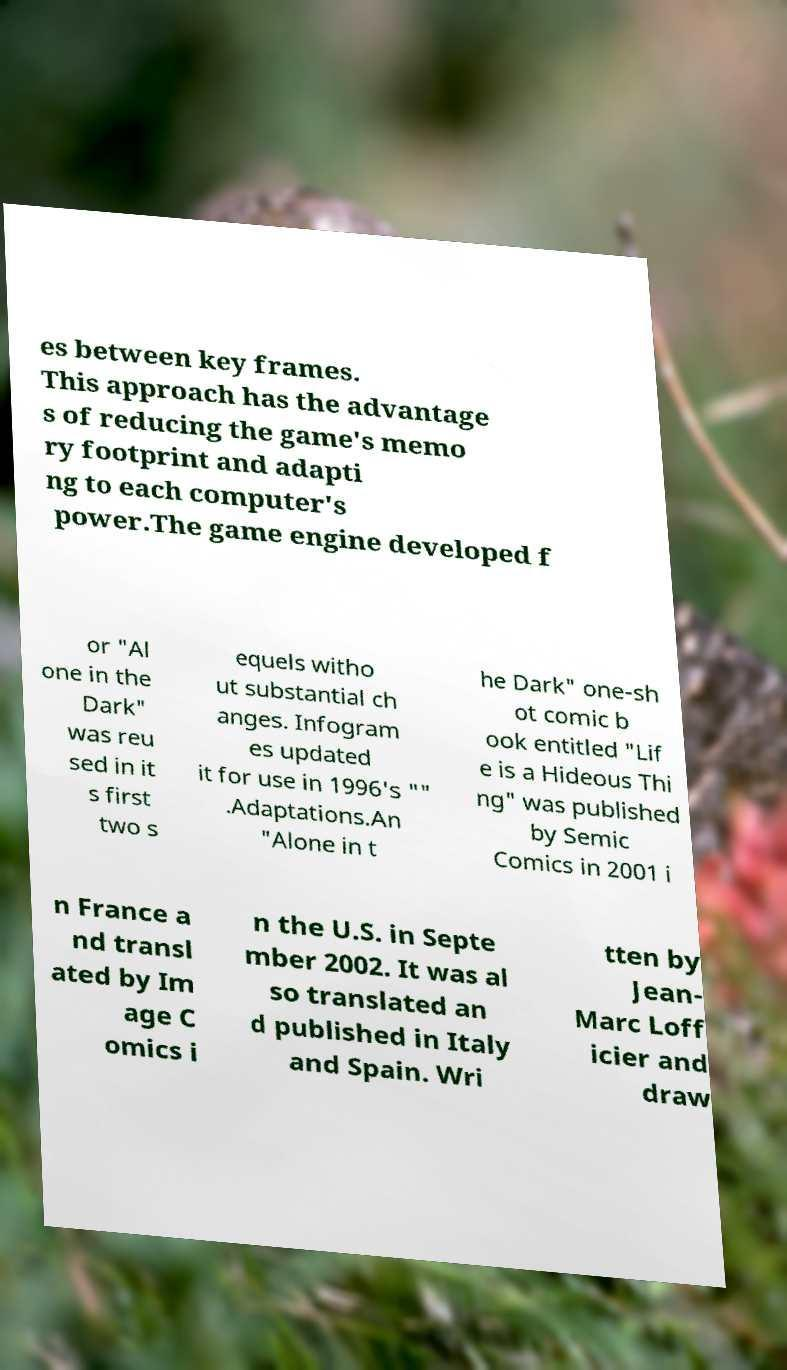Could you extract and type out the text from this image? es between key frames. This approach has the advantage s of reducing the game's memo ry footprint and adapti ng to each computer's power.The game engine developed f or "Al one in the Dark" was reu sed in it s first two s equels witho ut substantial ch anges. Infogram es updated it for use in 1996's "" .Adaptations.An "Alone in t he Dark" one-sh ot comic b ook entitled "Lif e is a Hideous Thi ng" was published by Semic Comics in 2001 i n France a nd transl ated by Im age C omics i n the U.S. in Septe mber 2002. It was al so translated an d published in Italy and Spain. Wri tten by Jean- Marc Loff icier and draw 